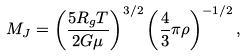<formula> <loc_0><loc_0><loc_500><loc_500>M _ { J } = \left ( \frac { 5 R _ { g } T } { 2 G \mu } \right ) ^ { 3 / 2 } \left ( \frac { 4 } { 3 } \pi \rho \right ) ^ { - 1 / 2 } ,</formula> 